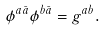Convert formula to latex. <formula><loc_0><loc_0><loc_500><loc_500>\phi ^ { a \bar { a } } \phi ^ { b \bar { a } } = g ^ { a b } .</formula> 